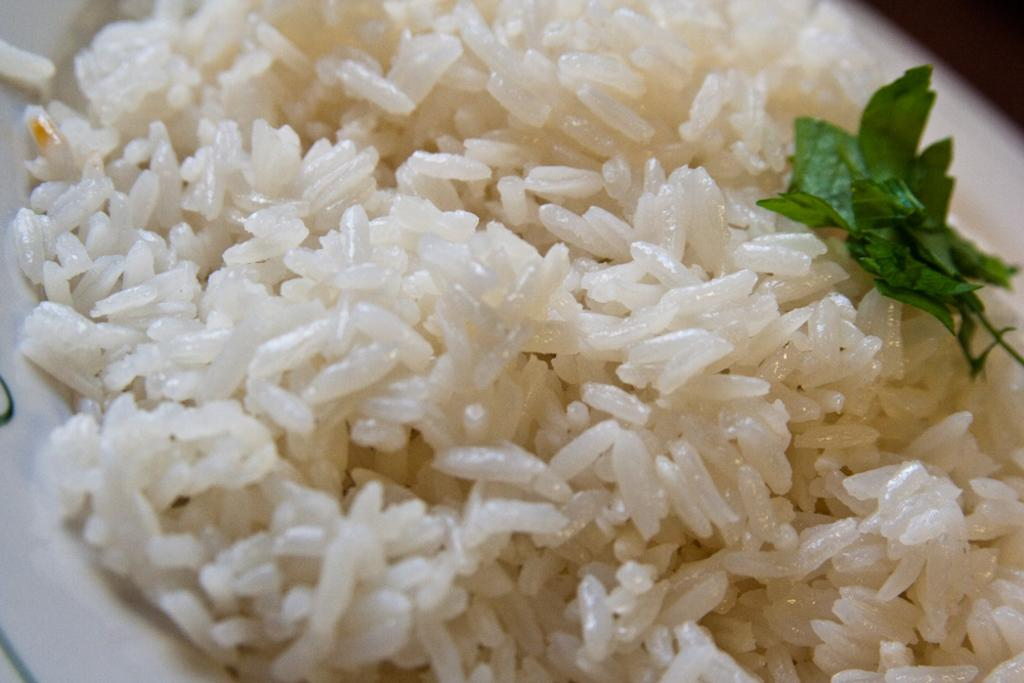What type of food is in the plate in the image? There is rice in a plate in the image. What type of flower is growing in the rice in the image? There is no flower present in the rice in the image. 